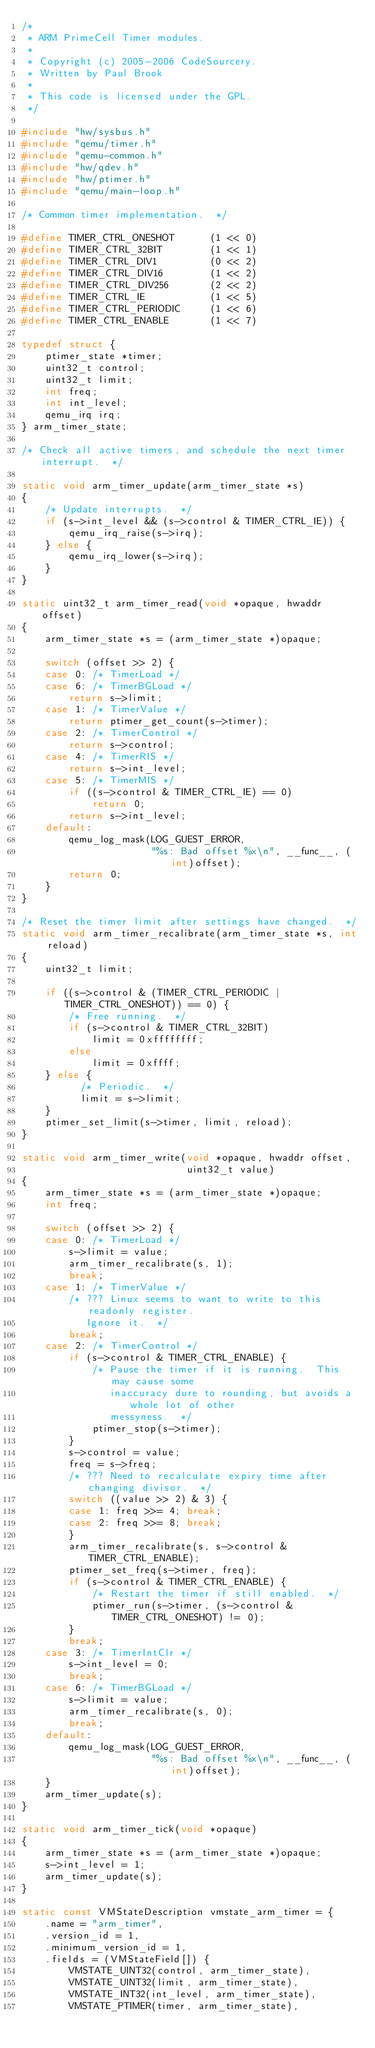Convert code to text. <code><loc_0><loc_0><loc_500><loc_500><_C_>/*
 * ARM PrimeCell Timer modules.
 *
 * Copyright (c) 2005-2006 CodeSourcery.
 * Written by Paul Brook
 *
 * This code is licensed under the GPL.
 */

#include "hw/sysbus.h"
#include "qemu/timer.h"
#include "qemu-common.h"
#include "hw/qdev.h"
#include "hw/ptimer.h"
#include "qemu/main-loop.h"

/* Common timer implementation.  */

#define TIMER_CTRL_ONESHOT      (1 << 0)
#define TIMER_CTRL_32BIT        (1 << 1)
#define TIMER_CTRL_DIV1         (0 << 2)
#define TIMER_CTRL_DIV16        (1 << 2)
#define TIMER_CTRL_DIV256       (2 << 2)
#define TIMER_CTRL_IE           (1 << 5)
#define TIMER_CTRL_PERIODIC     (1 << 6)
#define TIMER_CTRL_ENABLE       (1 << 7)

typedef struct {
    ptimer_state *timer;
    uint32_t control;
    uint32_t limit;
    int freq;
    int int_level;
    qemu_irq irq;
} arm_timer_state;

/* Check all active timers, and schedule the next timer interrupt.  */

static void arm_timer_update(arm_timer_state *s)
{
    /* Update interrupts.  */
    if (s->int_level && (s->control & TIMER_CTRL_IE)) {
        qemu_irq_raise(s->irq);
    } else {
        qemu_irq_lower(s->irq);
    }
}

static uint32_t arm_timer_read(void *opaque, hwaddr offset)
{
    arm_timer_state *s = (arm_timer_state *)opaque;

    switch (offset >> 2) {
    case 0: /* TimerLoad */
    case 6: /* TimerBGLoad */
        return s->limit;
    case 1: /* TimerValue */
        return ptimer_get_count(s->timer);
    case 2: /* TimerControl */
        return s->control;
    case 4: /* TimerRIS */
        return s->int_level;
    case 5: /* TimerMIS */
        if ((s->control & TIMER_CTRL_IE) == 0)
            return 0;
        return s->int_level;
    default:
        qemu_log_mask(LOG_GUEST_ERROR,
                      "%s: Bad offset %x\n", __func__, (int)offset);
        return 0;
    }
}

/* Reset the timer limit after settings have changed.  */
static void arm_timer_recalibrate(arm_timer_state *s, int reload)
{
    uint32_t limit;

    if ((s->control & (TIMER_CTRL_PERIODIC | TIMER_CTRL_ONESHOT)) == 0) {
        /* Free running.  */
        if (s->control & TIMER_CTRL_32BIT)
            limit = 0xffffffff;
        else
            limit = 0xffff;
    } else {
          /* Periodic.  */
          limit = s->limit;
    }
    ptimer_set_limit(s->timer, limit, reload);
}

static void arm_timer_write(void *opaque, hwaddr offset,
                            uint32_t value)
{
    arm_timer_state *s = (arm_timer_state *)opaque;
    int freq;

    switch (offset >> 2) {
    case 0: /* TimerLoad */
        s->limit = value;
        arm_timer_recalibrate(s, 1);
        break;
    case 1: /* TimerValue */
        /* ??? Linux seems to want to write to this readonly register.
           Ignore it.  */
        break;
    case 2: /* TimerControl */
        if (s->control & TIMER_CTRL_ENABLE) {
            /* Pause the timer if it is running.  This may cause some
               inaccuracy dure to rounding, but avoids a whole lot of other
               messyness.  */
            ptimer_stop(s->timer);
        }
        s->control = value;
        freq = s->freq;
        /* ??? Need to recalculate expiry time after changing divisor.  */
        switch ((value >> 2) & 3) {
        case 1: freq >>= 4; break;
        case 2: freq >>= 8; break;
        }
        arm_timer_recalibrate(s, s->control & TIMER_CTRL_ENABLE);
        ptimer_set_freq(s->timer, freq);
        if (s->control & TIMER_CTRL_ENABLE) {
            /* Restart the timer if still enabled.  */
            ptimer_run(s->timer, (s->control & TIMER_CTRL_ONESHOT) != 0);
        }
        break;
    case 3: /* TimerIntClr */
        s->int_level = 0;
        break;
    case 6: /* TimerBGLoad */
        s->limit = value;
        arm_timer_recalibrate(s, 0);
        break;
    default:
        qemu_log_mask(LOG_GUEST_ERROR,
                      "%s: Bad offset %x\n", __func__, (int)offset);
    }
    arm_timer_update(s);
}

static void arm_timer_tick(void *opaque)
{
    arm_timer_state *s = (arm_timer_state *)opaque;
    s->int_level = 1;
    arm_timer_update(s);
}

static const VMStateDescription vmstate_arm_timer = {
    .name = "arm_timer",
    .version_id = 1,
    .minimum_version_id = 1,
    .fields = (VMStateField[]) {
        VMSTATE_UINT32(control, arm_timer_state),
        VMSTATE_UINT32(limit, arm_timer_state),
        VMSTATE_INT32(int_level, arm_timer_state),
        VMSTATE_PTIMER(timer, arm_timer_state),</code> 